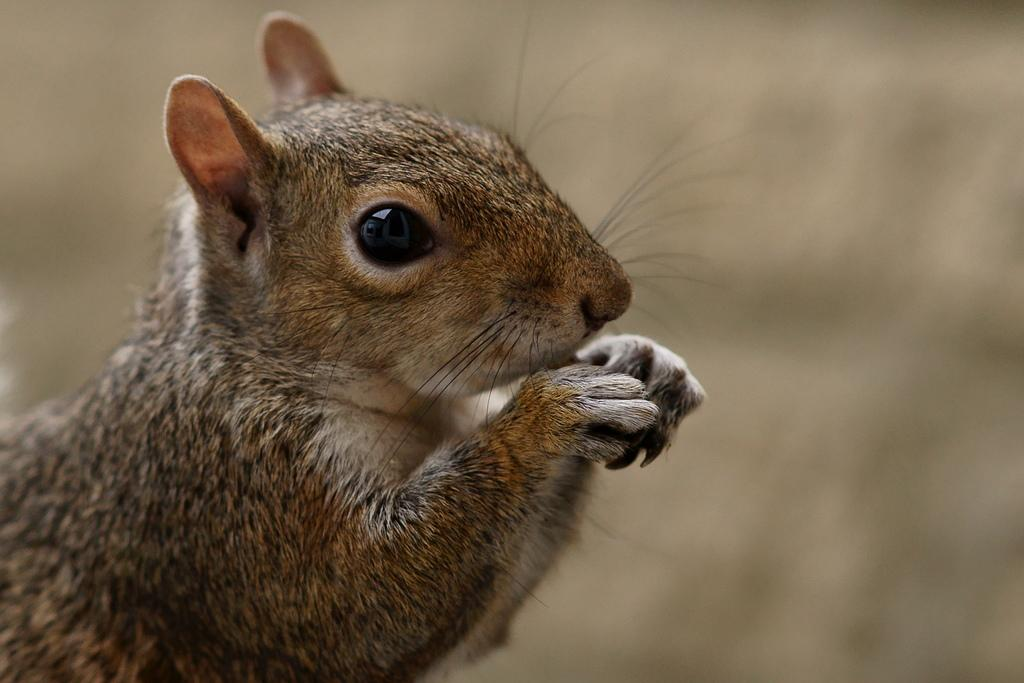What is the main subject in the foreground of the picture? There is a squirrel in the foreground of the picture. Can you describe the background of the image? The background of the image is blurred. What type of pen is the squirrel holding in the image? There is no pen present in the image; it features a squirrel in the foreground and a blurred background. What kind of beast can be seen lurking in the background of the image? There are no beasts visible in the image; it features a squirrel in the foreground and a blurred background. 